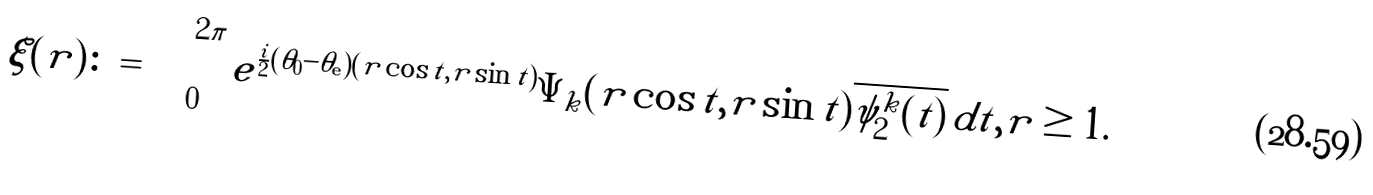<formula> <loc_0><loc_0><loc_500><loc_500>\xi ( r ) \colon = \int _ { 0 } ^ { 2 \pi } e ^ { \frac { i } { 2 } ( \theta _ { 0 } - \theta _ { \mathbf e } ) ( r \cos t , r \sin t ) } \Psi _ { k } ( r \cos t , r \sin t ) \overline { \psi ^ { k } _ { 2 } ( t ) } \, d t , r \geq 1 .</formula> 